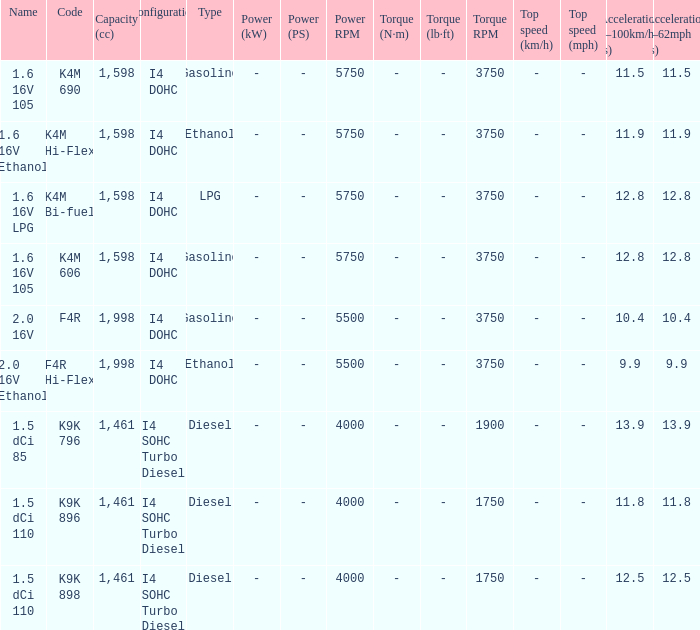Parse the table in full. {'header': ['Name', 'Code', 'Capacity (cc)', 'Configuration', 'Type', 'Power (kW)', 'Power (PS)', 'Power RPM', 'Torque (N·m)', 'Torque (lb·ft)', 'Torque RPM', 'Top speed (km/h)', 'Top speed (mph)', 'Acceleration 0–100km/h (s)', 'Acceleration 0–62mph (s)'], 'rows': [['1.6 16V 105', 'K4M 690', '1,598', 'I4 DOHC', 'Gasoline', '-', '-', '5750', '-', '-', '3750', '-', '-', '11.5', '11.5'], ['1.6 16V Ethanol', 'K4M Hi-Flex', '1,598', 'I4 DOHC', 'Ethanol', '-', '-', '5750', '-', '-', '3750', '-', '-', '11.9', '11.9'], ['1.6 16V LPG', 'K4M Bi-fuel', '1,598', 'I4 DOHC', 'LPG', '-', '-', '5750', '-', '-', '3750', '-', '-', '12.8', '12.8'], ['1.6 16V 105', 'K4M 606', '1,598', 'I4 DOHC', 'Gasoline', '-', '-', '5750', '-', '-', '3750', '-', '-', '12.8', '12.8'], ['2.0 16V', 'F4R', '1,998', 'I4 DOHC', 'Gasoline', '-', '-', '5500', '-', '-', '3750', '-', '-', '10.4', '10.4'], ['2.0 16V Ethanol', 'F4R Hi-Flex', '1,998', 'I4 DOHC', 'Ethanol', '-', '-', '5500', '-', '-', '3750', '-', '-', '9.9', '9.9'], ['1.5 dCi 85', 'K9K 796', '1,461', 'I4 SOHC Turbo Diesel', 'Diesel', '-', '-', '4000', '-', '-', '1900', '-', '-', '13.9', '13.9'], ['1.5 dCi 110', 'K9K 896', '1,461', 'I4 SOHC Turbo Diesel', 'Diesel', '-', '-', '4000', '-', '-', '1750', '-', '-', '11.8', '11.8'], ['1.5 dCi 110', 'K9K 898', '1,461', 'I4 SOHC Turbo Diesel', 'Diesel', '-', '-', '4000', '-', '-', '1750', '-', '-', '12.5', '12.5']]} What is the capacity of code f4r? 1,998cc. 